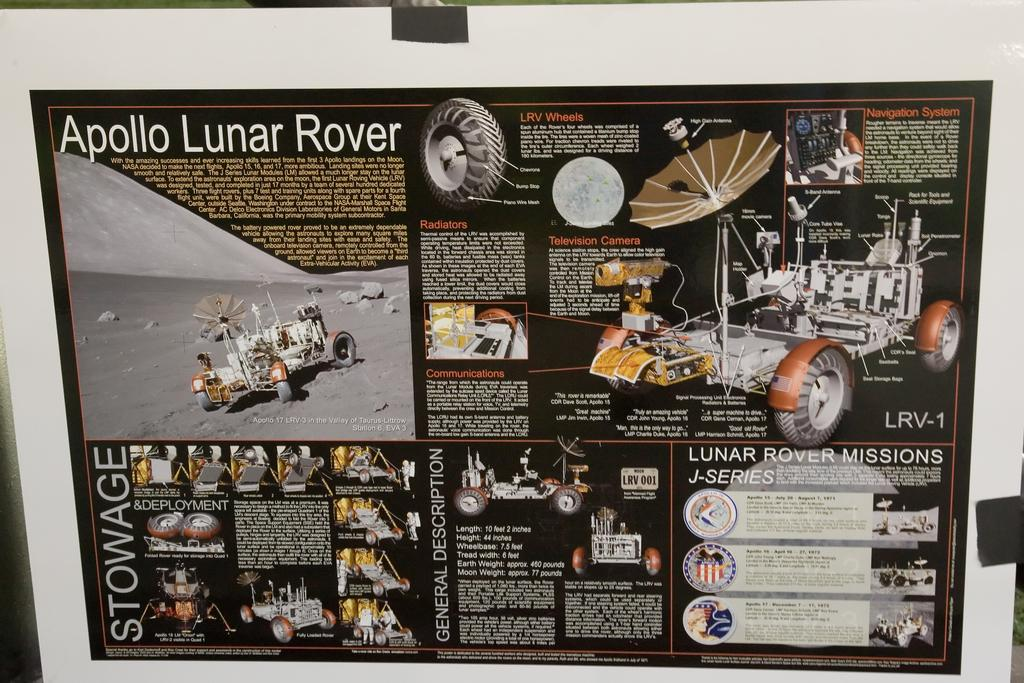Provide a one-sentence caption for the provided image. A Apollo Lunar Rover poster with a picture of the rover and a detail description of the rover. 